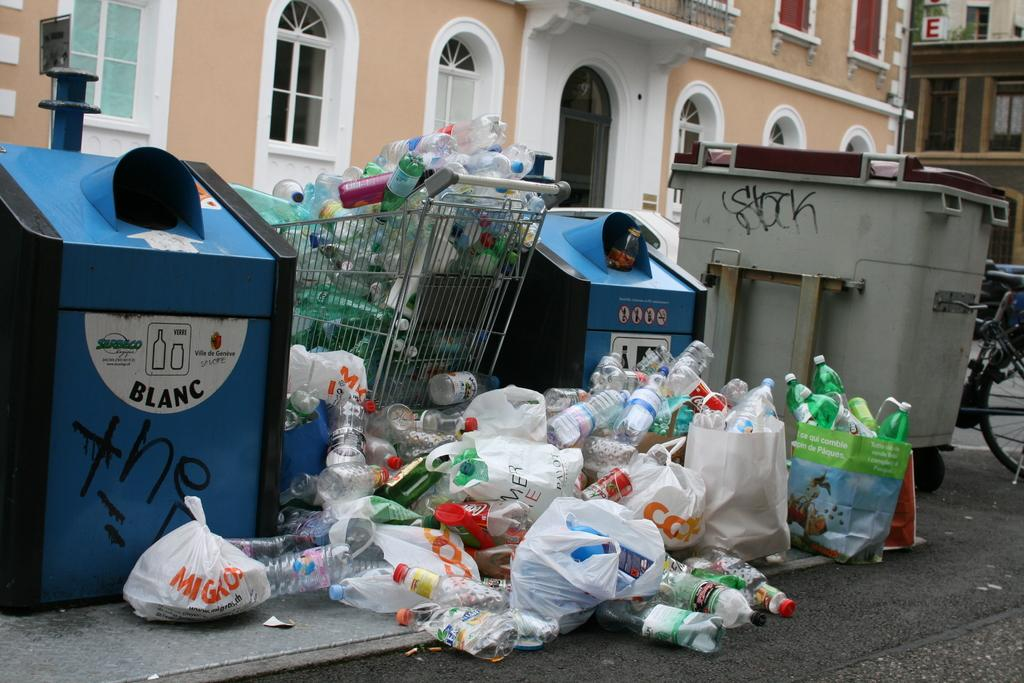<image>
Relay a brief, clear account of the picture shown. Garbage in front of a blue garbage can that says BLANC on it. 